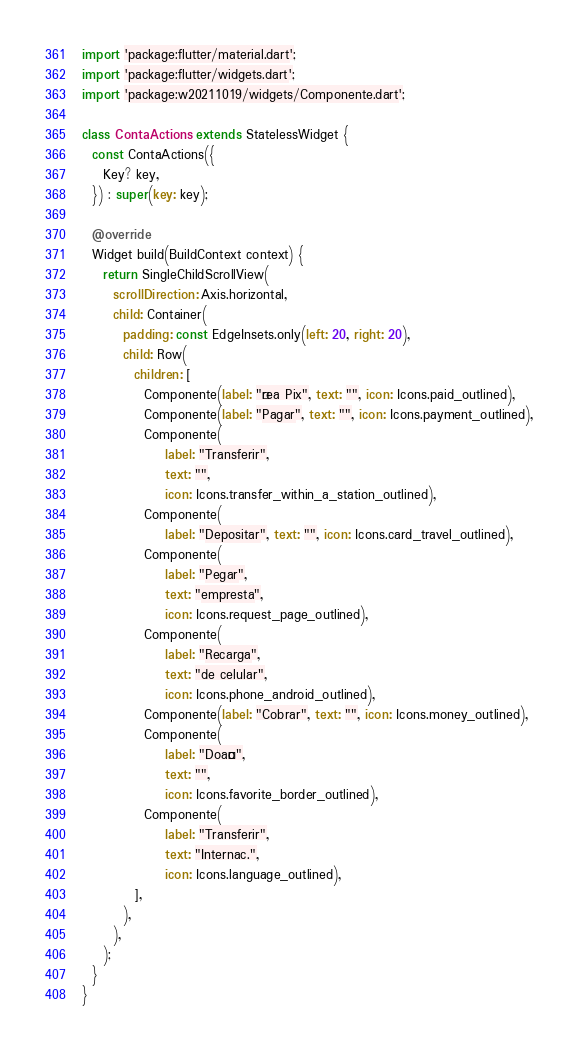<code> <loc_0><loc_0><loc_500><loc_500><_Dart_>import 'package:flutter/material.dart';
import 'package:flutter/widgets.dart';
import 'package:w20211019/widgets/Componente.dart';

class ContaActions extends StatelessWidget {
  const ContaActions({
    Key? key,
  }) : super(key: key);

  @override
  Widget build(BuildContext context) {
    return SingleChildScrollView(
      scrollDirection: Axis.horizontal,
      child: Container(
        padding: const EdgeInsets.only(left: 20, right: 20),
        child: Row(
          children: [
            Componente(label: "Área Pix", text: "", icon: Icons.paid_outlined),
            Componente(label: "Pagar", text: "", icon: Icons.payment_outlined),
            Componente(
                label: "Transferir",
                text: "",
                icon: Icons.transfer_within_a_station_outlined),
            Componente(
                label: "Depositar", text: "", icon: Icons.card_travel_outlined),
            Componente(
                label: "Pegar",
                text: "empresta",
                icon: Icons.request_page_outlined),
            Componente(
                label: "Recarga",
                text: "de celular",
                icon: Icons.phone_android_outlined),
            Componente(label: "Cobrar", text: "", icon: Icons.money_outlined),
            Componente(
                label: "Doação",
                text: "",
                icon: Icons.favorite_border_outlined),
            Componente(
                label: "Transferir",
                text: "Internac.",
                icon: Icons.language_outlined),
          ],
        ),
      ),
    );
  }
}
</code> 